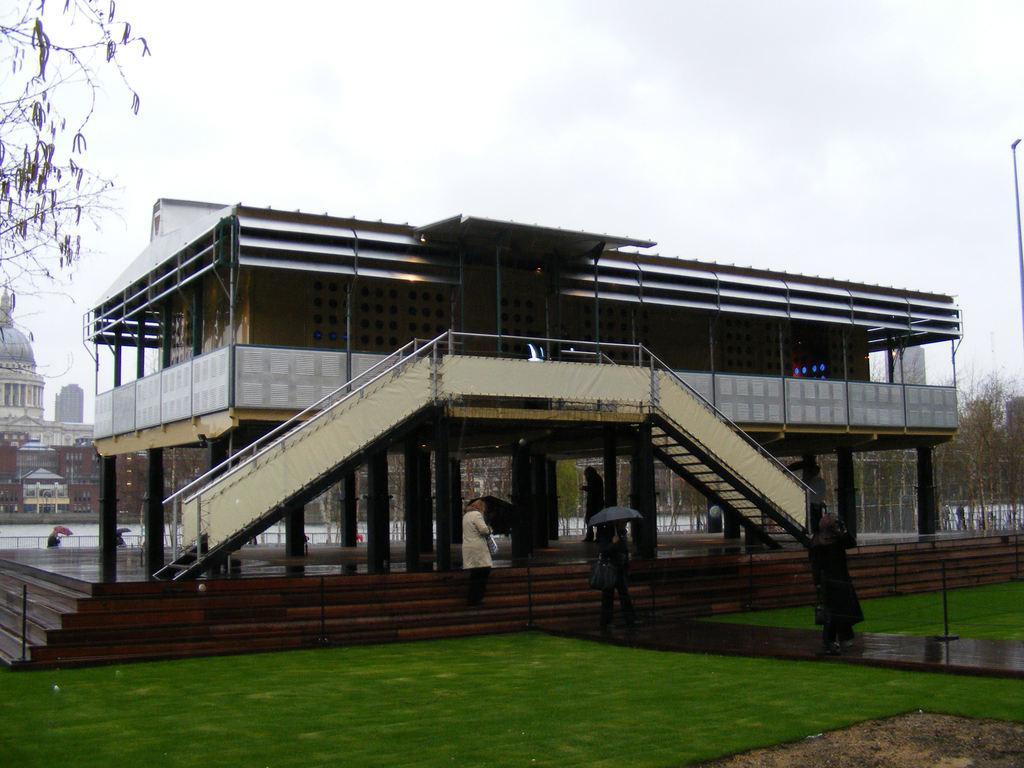Describe this image in one or two sentences. In this image I can see grass, buildings, trees and here I can see few people are standing. I can also see most of them are holding umbrellas and in background I can see the sky. 